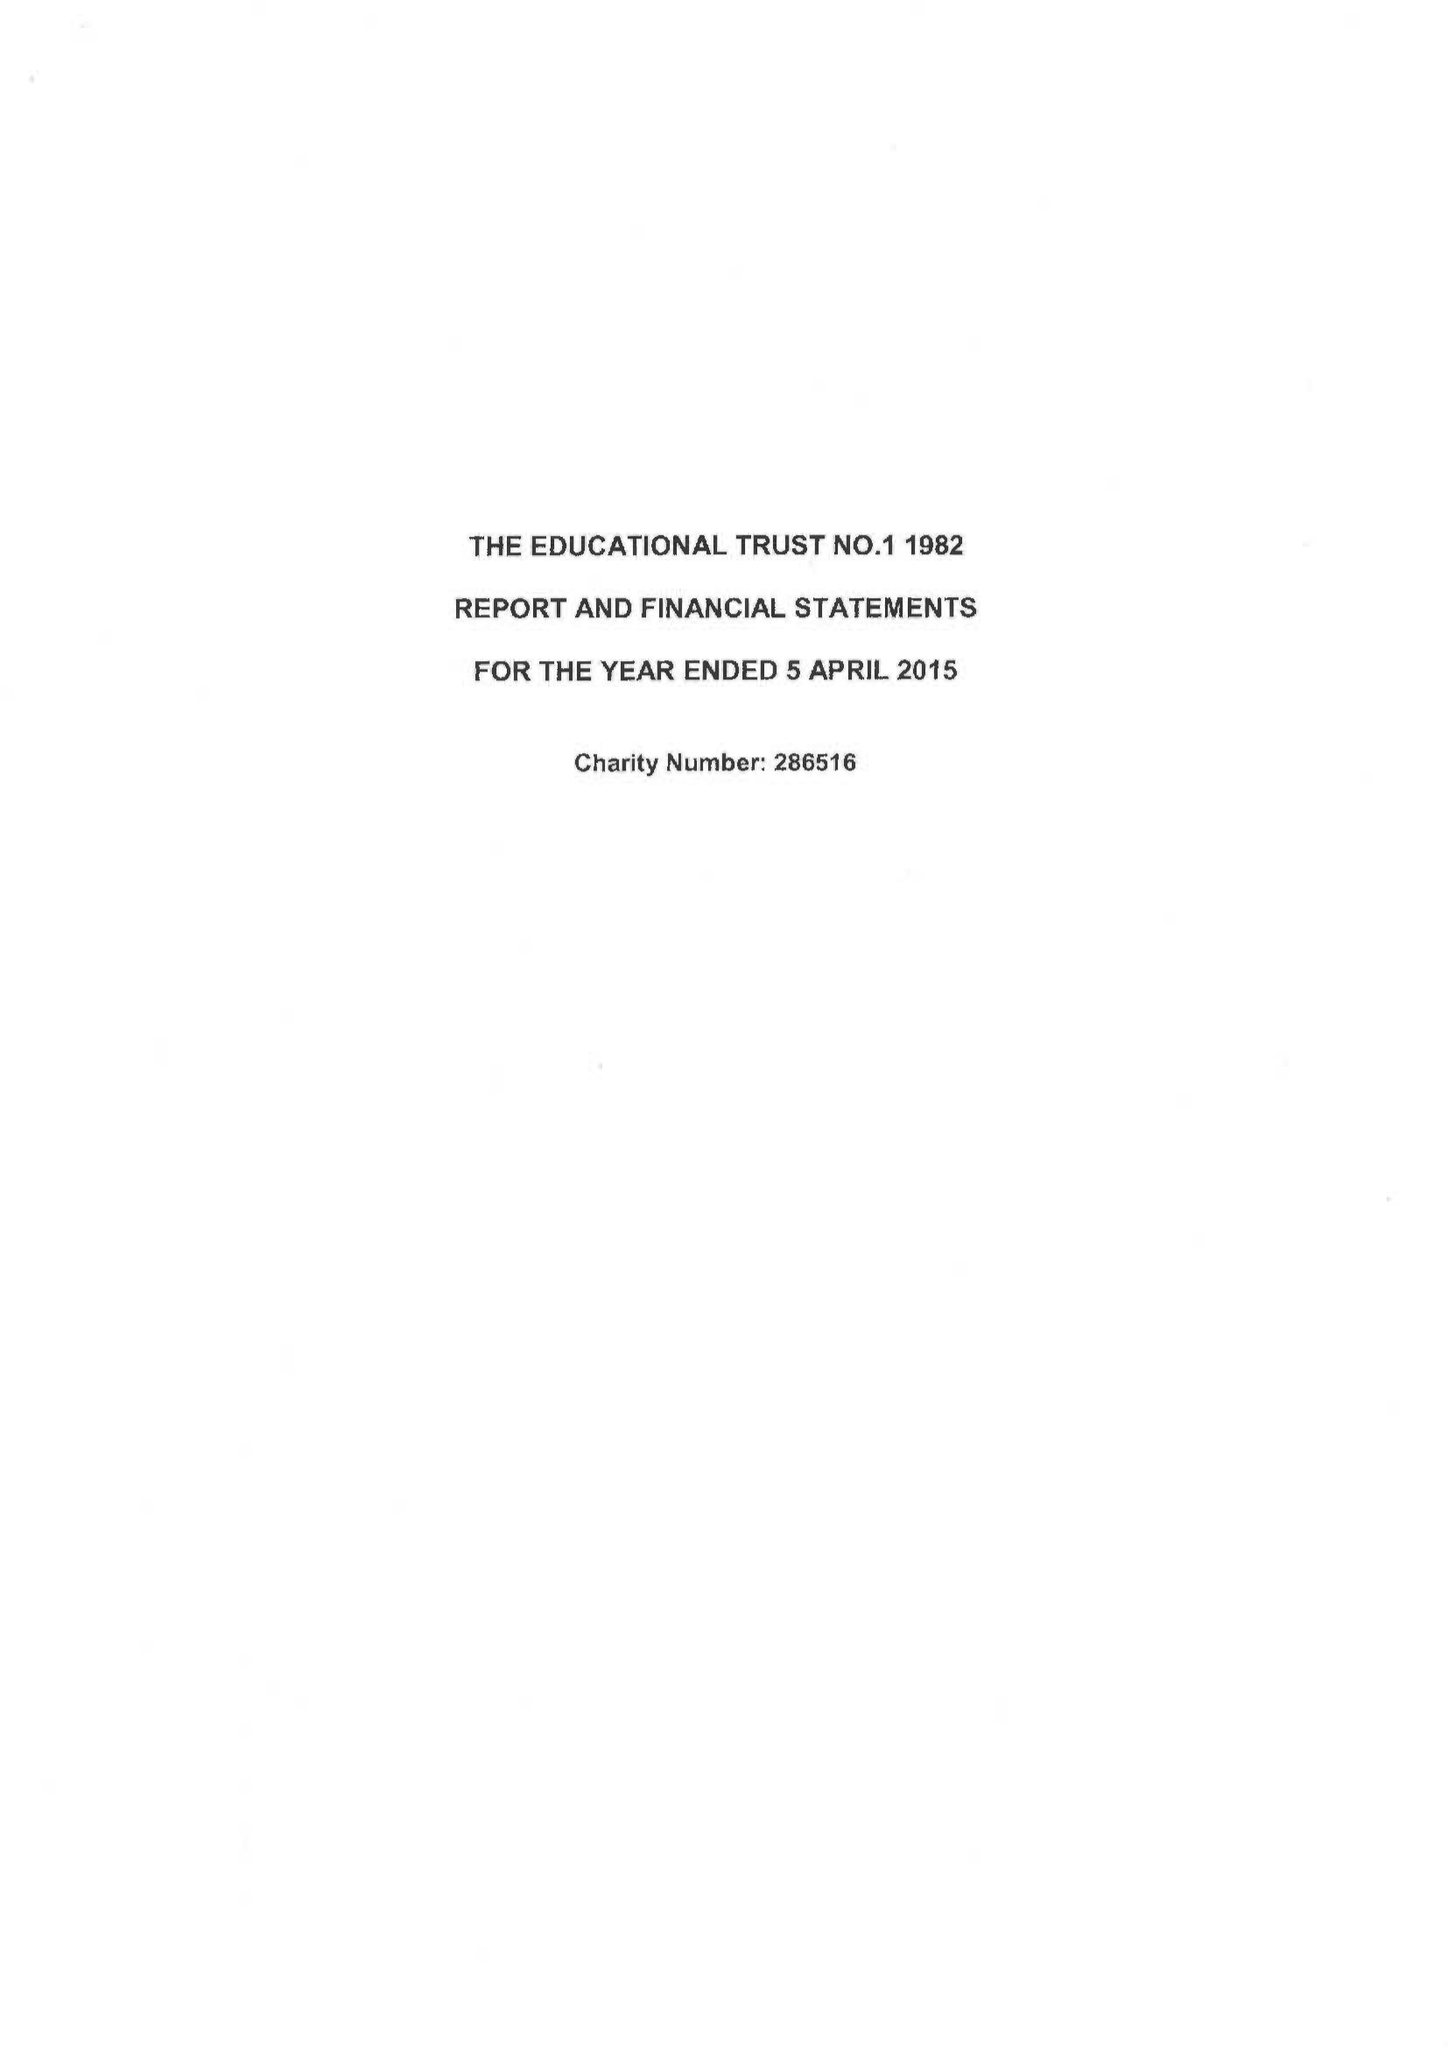What is the value for the report_date?
Answer the question using a single word or phrase. 2015-04-05 